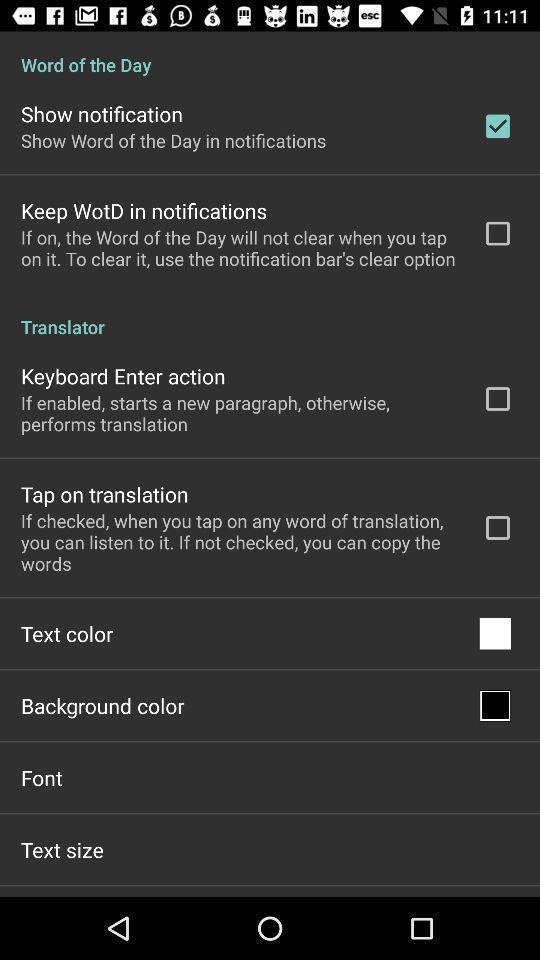Tell me about the visual elements in this screen capture. Various setting options in the application. 